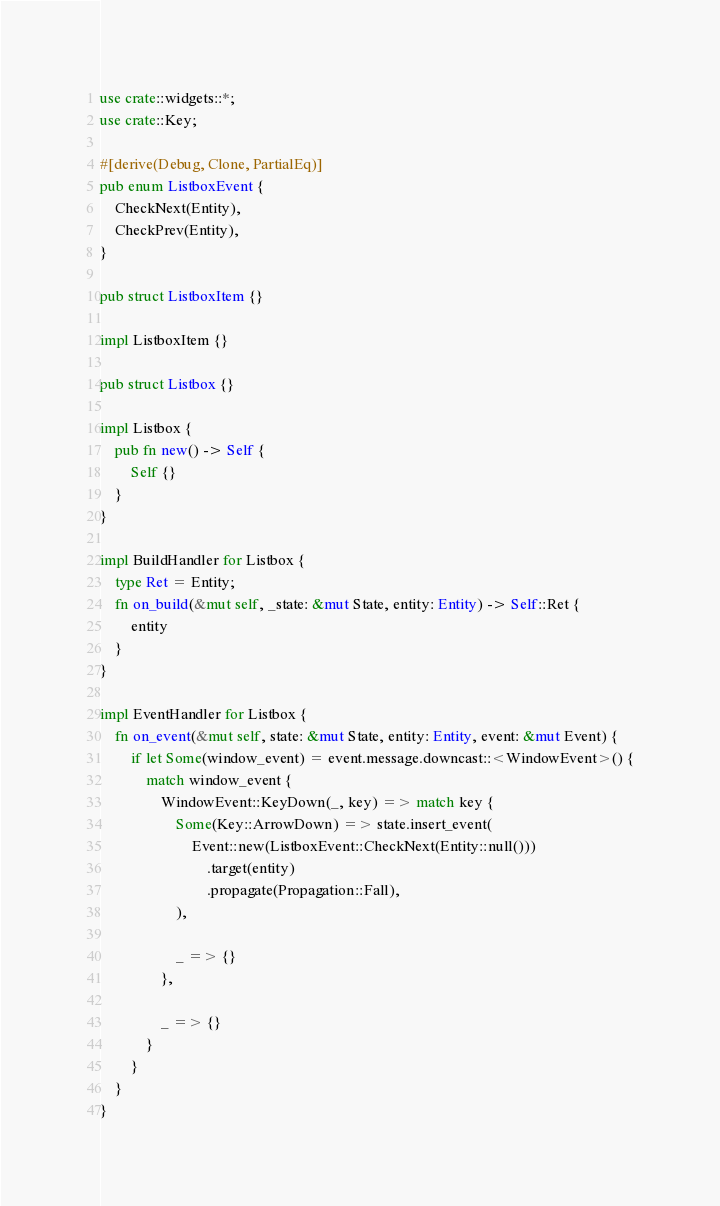<code> <loc_0><loc_0><loc_500><loc_500><_Rust_>use crate::widgets::*;
use crate::Key;

#[derive(Debug, Clone, PartialEq)]
pub enum ListboxEvent {
    CheckNext(Entity),
    CheckPrev(Entity),
}

pub struct ListboxItem {}

impl ListboxItem {}

pub struct Listbox {}

impl Listbox {
    pub fn new() -> Self {
        Self {}
    }
}

impl BuildHandler for Listbox {
    type Ret = Entity;
    fn on_build(&mut self, _state: &mut State, entity: Entity) -> Self::Ret {
        entity
    }
}

impl EventHandler for Listbox {
    fn on_event(&mut self, state: &mut State, entity: Entity, event: &mut Event) {
        if let Some(window_event) = event.message.downcast::<WindowEvent>() {
            match window_event {
                WindowEvent::KeyDown(_, key) => match key {
                    Some(Key::ArrowDown) => state.insert_event(
                        Event::new(ListboxEvent::CheckNext(Entity::null()))
                            .target(entity)
                            .propagate(Propagation::Fall),
                    ),

                    _ => {}
                },

                _ => {}
            }
        }
    }
}
</code> 